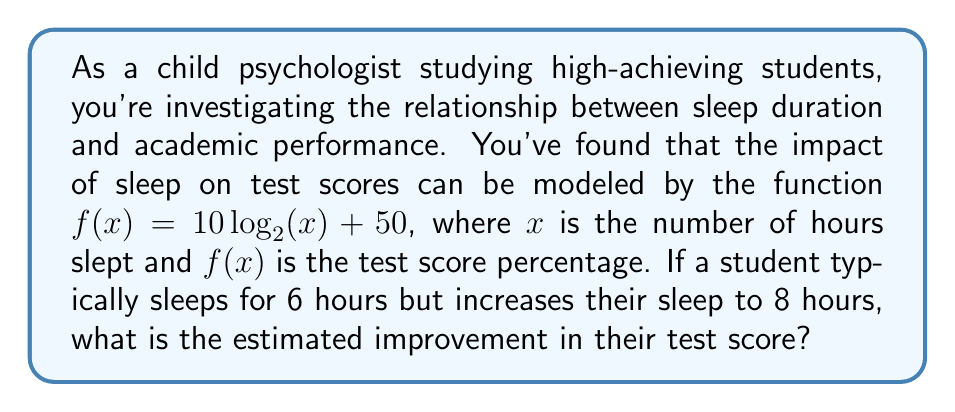Help me with this question. Let's approach this step-by-step:

1) We need to calculate the difference between $f(8)$ and $f(6)$.

2) First, let's calculate $f(8)$:
   $f(8) = 10 \log_{2}(8) + 50$
   $= 10 \cdot 3 + 50$ (since $2^3 = 8$)
   $= 30 + 50 = 80$

3) Now, let's calculate $f(6)$:
   $f(6) = 10 \log_{2}(6) + 50$
   $= 10 \cdot \log_{2}(6) + 50$
   $\approx 10 \cdot 2.585 + 50$
   $\approx 25.85 + 50 = 75.85$

4) The improvement is the difference between these two values:
   $80 - 75.85 = 4.15$

5) Therefore, the estimated improvement in the test score is approximately 4.15 percentage points.
Answer: 4.15 percentage points 